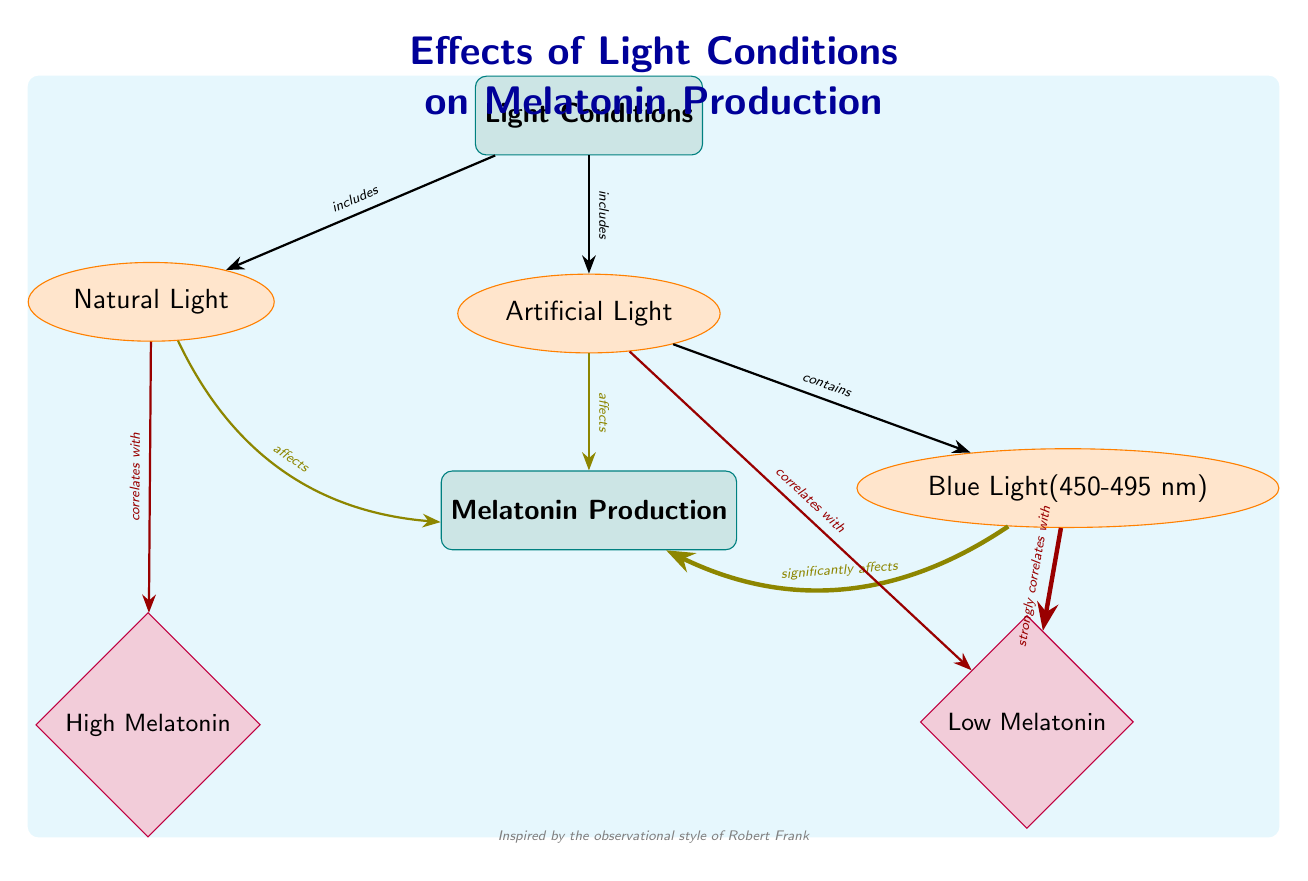What are the categories of light conditions represented in the diagram? The diagram lists two categories of light conditions: Natural Light and Artificial Light. These are shown as subcategories connected to the main category labeled "Light Conditions."
Answer: Natural Light, Artificial Light Which light condition significantly affects melatonin production? The diagram indicates that Blue Light significantly affects melatonin production through a bold edge labeled "significantly affects," linking it to the Melatonin Production node.
Answer: Blue Light How many nodes are present related to melatonin production? The diagram contains two effect nodes related to melatonin production: High Melatonin and Low Melatonin, which are positioned below the Melatonin Production node. Therefore, the total is two.
Answer: 2 What is the correlation between natural light and melatonin levels? According to the diagram, natural light correlates with high melatonin production, as indicated by the edge labeled "correlates with" connecting Natural Light to High Melatonin.
Answer: High Melatonin What can be inferred about artificial light's effect on melatonin levels? The diagram shows that artificial light correlates with low melatonin production, evidenced by the edge labeled "correlates with" linking Artificial Light to Low Melatonin. This implies that exposure to artificial light reduces melatonin levels.
Answer: Low Melatonin Which type of light is associated with a strong correlation to low melatonin production? The diagram clearly indicates that Blue Light has a strong correlation to low melatonin production, as shown by the ultra-thick edge labeled "strongly correlates with," pointing to the Low Melatonin node.
Answer: Blue Light Does natural light have any effect on melatonin production? Yes, the diagram shows that natural light affects melatonin production, as indicated by the edge labeled "affects" connecting Natural Light to the Melatonin Production node, suggesting it plays a role in regulating melatonin levels.
Answer: Yes Which edge type is used to connect artificial light to melatonin production? The edge connecting artificial light to melatonin production is a standard line that indicates an effect. It is labeled "affects," suggesting a direct influence of artificial light on melatonin levels.
Answer: Affects 